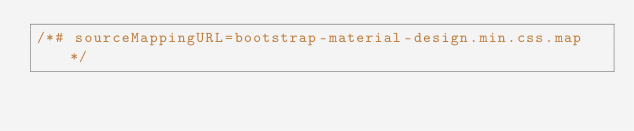Convert code to text. <code><loc_0><loc_0><loc_500><loc_500><_CSS_>/*# sourceMappingURL=bootstrap-material-design.min.css.map */</code> 